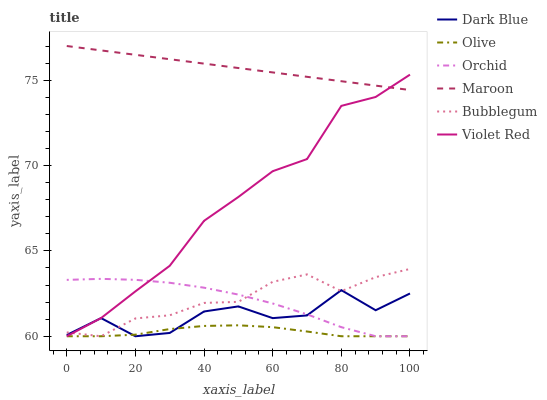Does Olive have the minimum area under the curve?
Answer yes or no. Yes. Does Maroon have the maximum area under the curve?
Answer yes or no. Yes. Does Bubblegum have the minimum area under the curve?
Answer yes or no. No. Does Bubblegum have the maximum area under the curve?
Answer yes or no. No. Is Maroon the smoothest?
Answer yes or no. Yes. Is Dark Blue the roughest?
Answer yes or no. Yes. Is Bubblegum the smoothest?
Answer yes or no. No. Is Bubblegum the roughest?
Answer yes or no. No. Does Maroon have the lowest value?
Answer yes or no. No. Does Maroon have the highest value?
Answer yes or no. Yes. Does Bubblegum have the highest value?
Answer yes or no. No. Is Olive less than Maroon?
Answer yes or no. Yes. Is Maroon greater than Bubblegum?
Answer yes or no. Yes. Does Violet Red intersect Olive?
Answer yes or no. Yes. Is Violet Red less than Olive?
Answer yes or no. No. Is Violet Red greater than Olive?
Answer yes or no. No. Does Olive intersect Maroon?
Answer yes or no. No. 